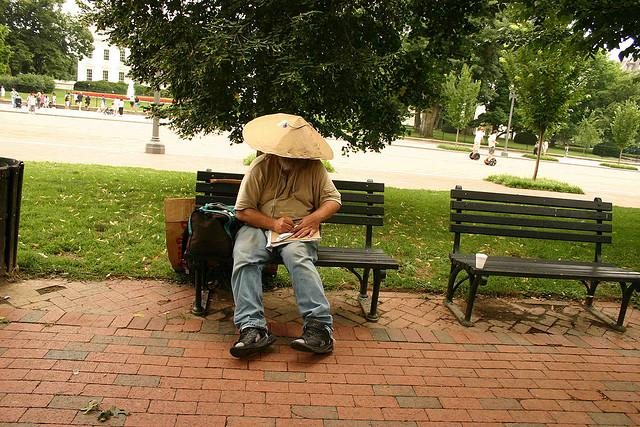What purpose does the large disk on this person's head serve most here? Please explain your reasoning. sun. This person is wearing this in the sun, and this would not hold up in the rain. no one wears a hat to protect from the moon. 